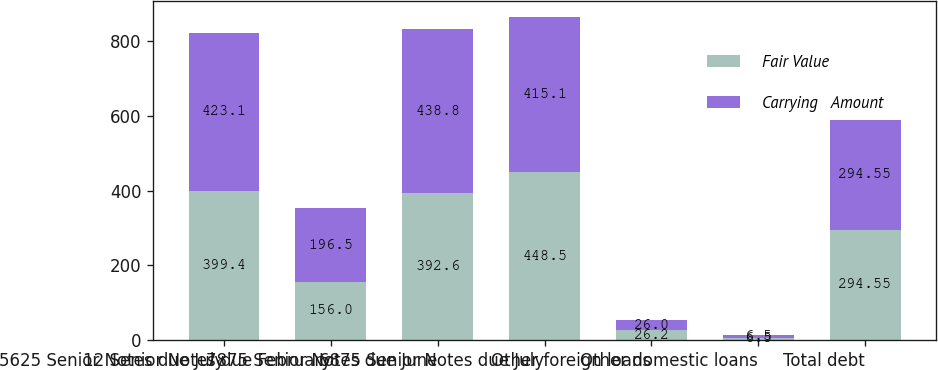Convert chart to OTSL. <chart><loc_0><loc_0><loc_500><loc_500><stacked_bar_chart><ecel><fcel>5625 Senior Notes due July<fcel>12 Senior Notes due February<fcel>7875 Senior Notes due June<fcel>6875 Senior Notes due July<fcel>Other foreign loans<fcel>Other domestic loans<fcel>Total debt<nl><fcel>Fair Value<fcel>399.4<fcel>156<fcel>392.6<fcel>448.5<fcel>26.2<fcel>6.5<fcel>294.55<nl><fcel>Carrying   Amount<fcel>423.1<fcel>196.5<fcel>438.8<fcel>415.1<fcel>26<fcel>6.5<fcel>294.55<nl></chart> 